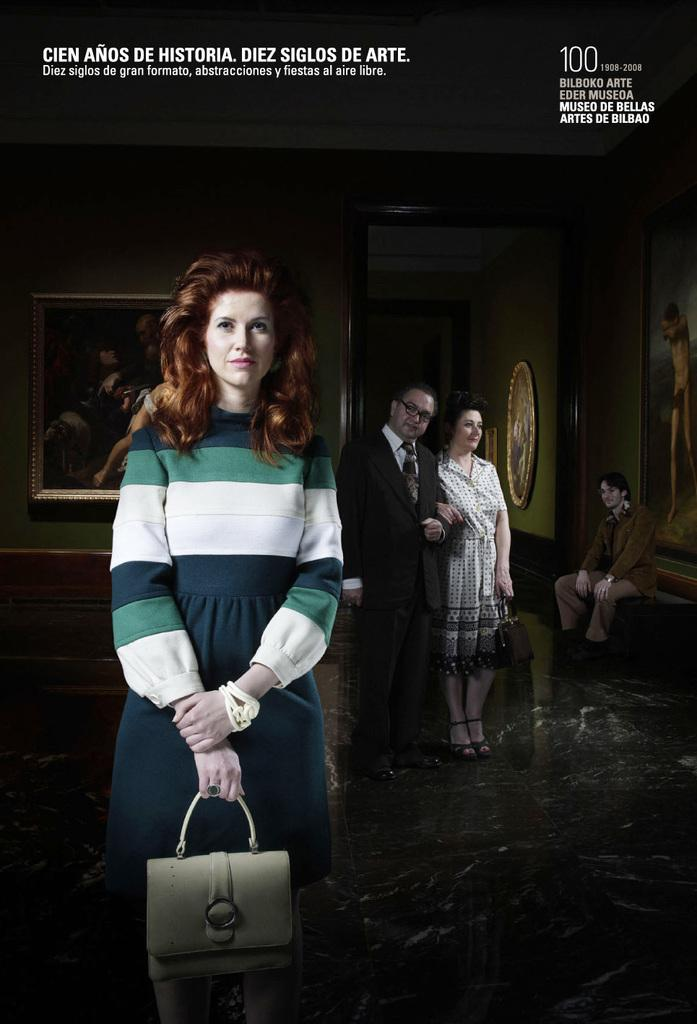Who can be seen in the image? There are people in the image. Can you describe one of the individuals in the image? There is a woman in the image. What is the woman holding? The woman is holding a bag. What can be seen in the background of the image? There are paintings on the walls in the background of the image. What type of slope can be seen in the image? There is no slope present in the image. What color is the pencil being used by the woman in the image? There is no pencil visible in the image; the woman is holding a bag. 